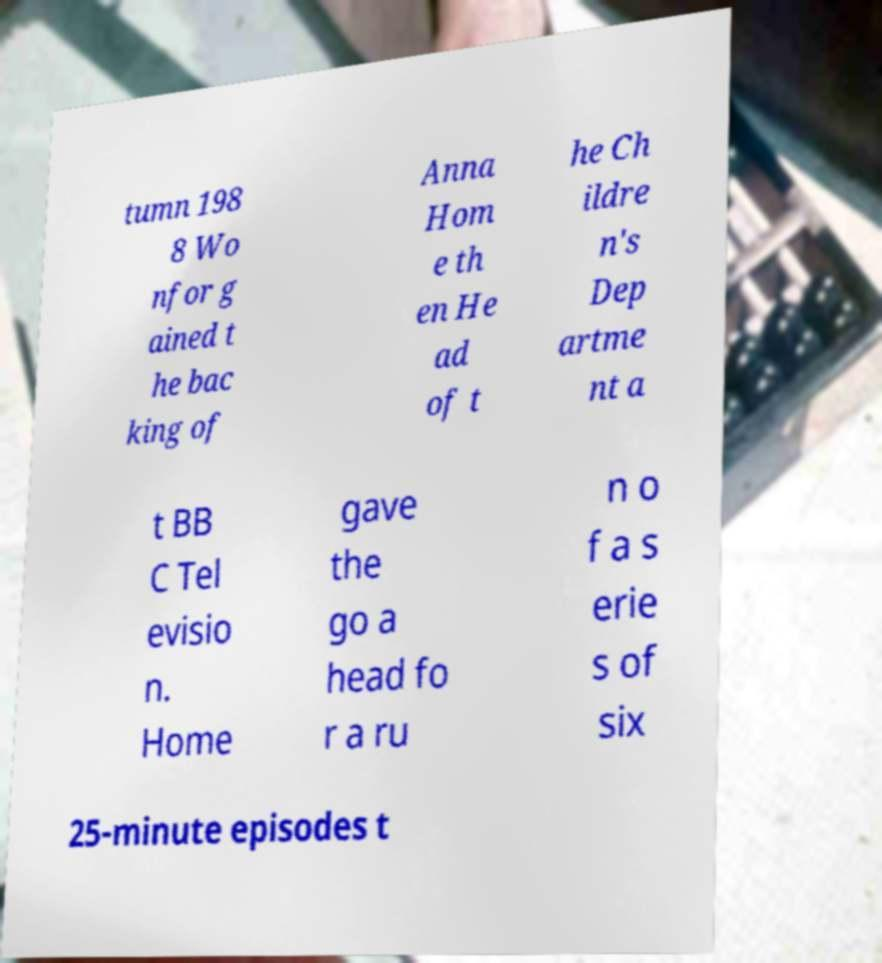Can you accurately transcribe the text from the provided image for me? tumn 198 8 Wo nfor g ained t he bac king of Anna Hom e th en He ad of t he Ch ildre n's Dep artme nt a t BB C Tel evisio n. Home gave the go a head fo r a ru n o f a s erie s of six 25-minute episodes t 